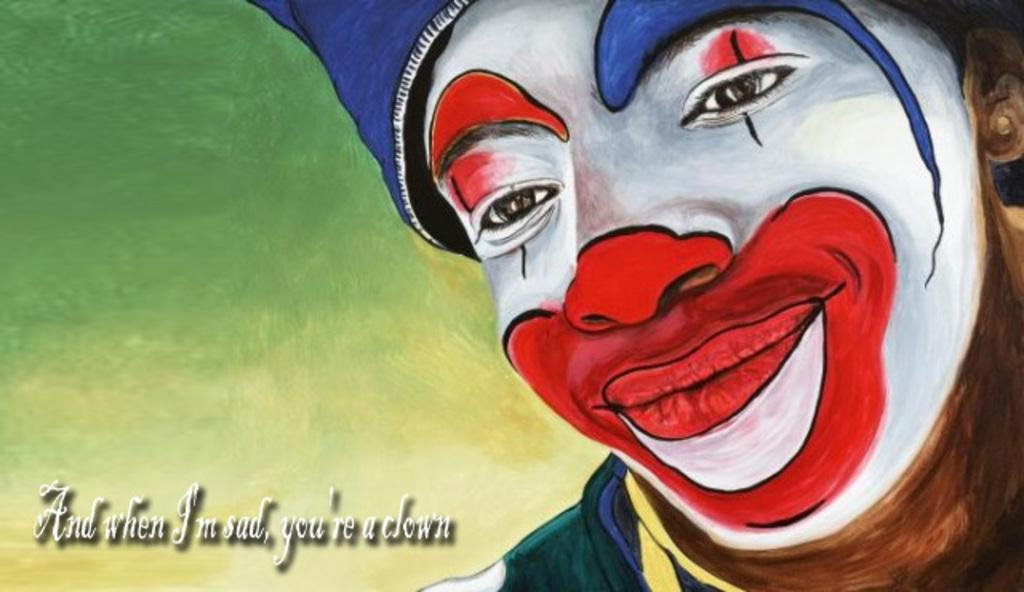What character can be seen in the image? There is a clown in the image. Where is the clown positioned in the image? The clown is located at the right side of the image. What additional text is present in the image? There is a quote written in the image. Where is the quote located in the image? The quote is located at the left bottom of the image. What type of lumber is being used to build the company's headquarters in the image? There is no mention of lumber or a company's headquarters in the image; it features a clown and a quote. 